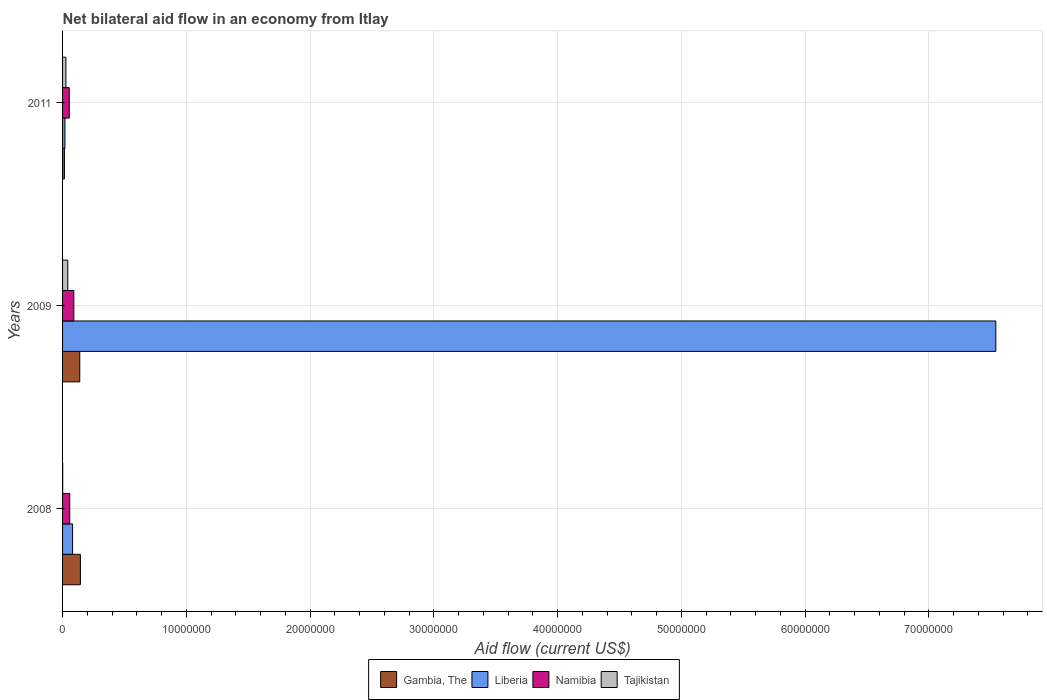How many different coloured bars are there?
Your answer should be compact. 4. How many groups of bars are there?
Offer a very short reply. 3. Are the number of bars per tick equal to the number of legend labels?
Offer a very short reply. Yes. Are the number of bars on each tick of the Y-axis equal?
Your response must be concise. Yes. How many bars are there on the 1st tick from the top?
Your answer should be compact. 4. How many bars are there on the 3rd tick from the bottom?
Make the answer very short. 4. In how many cases, is the number of bars for a given year not equal to the number of legend labels?
Offer a terse response. 0. What is the net bilateral aid flow in Liberia in 2008?
Provide a short and direct response. 8.10e+05. Across all years, what is the maximum net bilateral aid flow in Gambia, The?
Your answer should be compact. 1.44e+06. In which year was the net bilateral aid flow in Namibia minimum?
Keep it short and to the point. 2011. What is the difference between the net bilateral aid flow in Namibia in 2009 and that in 2011?
Provide a short and direct response. 3.70e+05. What is the difference between the net bilateral aid flow in Tajikistan in 2011 and the net bilateral aid flow in Liberia in 2008?
Offer a terse response. -5.40e+05. What is the average net bilateral aid flow in Liberia per year?
Your response must be concise. 2.55e+07. What is the ratio of the net bilateral aid flow in Namibia in 2008 to that in 2009?
Your answer should be very brief. 0.64. What is the difference between the highest and the second highest net bilateral aid flow in Liberia?
Provide a succinct answer. 7.46e+07. What is the difference between the highest and the lowest net bilateral aid flow in Tajikistan?
Offer a very short reply. 4.10e+05. What does the 1st bar from the top in 2009 represents?
Give a very brief answer. Tajikistan. What does the 1st bar from the bottom in 2011 represents?
Your answer should be very brief. Gambia, The. How many years are there in the graph?
Your answer should be very brief. 3. What is the difference between two consecutive major ticks on the X-axis?
Give a very brief answer. 1.00e+07. Does the graph contain any zero values?
Provide a succinct answer. No. Where does the legend appear in the graph?
Ensure brevity in your answer.  Bottom center. What is the title of the graph?
Offer a very short reply. Net bilateral aid flow in an economy from Itlay. What is the label or title of the X-axis?
Give a very brief answer. Aid flow (current US$). What is the label or title of the Y-axis?
Give a very brief answer. Years. What is the Aid flow (current US$) of Gambia, The in 2008?
Give a very brief answer. 1.44e+06. What is the Aid flow (current US$) in Liberia in 2008?
Your response must be concise. 8.10e+05. What is the Aid flow (current US$) in Namibia in 2008?
Your response must be concise. 5.80e+05. What is the Aid flow (current US$) in Tajikistan in 2008?
Your answer should be compact. 10000. What is the Aid flow (current US$) in Gambia, The in 2009?
Your answer should be very brief. 1.39e+06. What is the Aid flow (current US$) in Liberia in 2009?
Offer a very short reply. 7.54e+07. What is the Aid flow (current US$) in Namibia in 2009?
Offer a very short reply. 9.10e+05. What is the Aid flow (current US$) in Tajikistan in 2009?
Provide a succinct answer. 4.20e+05. What is the Aid flow (current US$) of Gambia, The in 2011?
Provide a succinct answer. 1.50e+05. What is the Aid flow (current US$) of Liberia in 2011?
Your answer should be compact. 1.90e+05. What is the Aid flow (current US$) of Namibia in 2011?
Provide a succinct answer. 5.40e+05. Across all years, what is the maximum Aid flow (current US$) in Gambia, The?
Your response must be concise. 1.44e+06. Across all years, what is the maximum Aid flow (current US$) of Liberia?
Offer a terse response. 7.54e+07. Across all years, what is the maximum Aid flow (current US$) in Namibia?
Give a very brief answer. 9.10e+05. Across all years, what is the maximum Aid flow (current US$) in Tajikistan?
Your answer should be very brief. 4.20e+05. Across all years, what is the minimum Aid flow (current US$) of Gambia, The?
Keep it short and to the point. 1.50e+05. Across all years, what is the minimum Aid flow (current US$) of Liberia?
Offer a very short reply. 1.90e+05. Across all years, what is the minimum Aid flow (current US$) in Namibia?
Your answer should be very brief. 5.40e+05. What is the total Aid flow (current US$) in Gambia, The in the graph?
Offer a terse response. 2.98e+06. What is the total Aid flow (current US$) of Liberia in the graph?
Give a very brief answer. 7.64e+07. What is the total Aid flow (current US$) of Namibia in the graph?
Offer a terse response. 2.03e+06. What is the total Aid flow (current US$) in Tajikistan in the graph?
Keep it short and to the point. 7.00e+05. What is the difference between the Aid flow (current US$) of Liberia in 2008 and that in 2009?
Make the answer very short. -7.46e+07. What is the difference between the Aid flow (current US$) of Namibia in 2008 and that in 2009?
Provide a succinct answer. -3.30e+05. What is the difference between the Aid flow (current US$) of Tajikistan in 2008 and that in 2009?
Make the answer very short. -4.10e+05. What is the difference between the Aid flow (current US$) of Gambia, The in 2008 and that in 2011?
Give a very brief answer. 1.29e+06. What is the difference between the Aid flow (current US$) of Liberia in 2008 and that in 2011?
Provide a short and direct response. 6.20e+05. What is the difference between the Aid flow (current US$) of Namibia in 2008 and that in 2011?
Provide a short and direct response. 4.00e+04. What is the difference between the Aid flow (current US$) in Gambia, The in 2009 and that in 2011?
Your response must be concise. 1.24e+06. What is the difference between the Aid flow (current US$) in Liberia in 2009 and that in 2011?
Offer a terse response. 7.52e+07. What is the difference between the Aid flow (current US$) in Namibia in 2009 and that in 2011?
Your answer should be compact. 3.70e+05. What is the difference between the Aid flow (current US$) in Tajikistan in 2009 and that in 2011?
Your answer should be compact. 1.50e+05. What is the difference between the Aid flow (current US$) of Gambia, The in 2008 and the Aid flow (current US$) of Liberia in 2009?
Your answer should be compact. -7.40e+07. What is the difference between the Aid flow (current US$) in Gambia, The in 2008 and the Aid flow (current US$) in Namibia in 2009?
Keep it short and to the point. 5.30e+05. What is the difference between the Aid flow (current US$) of Gambia, The in 2008 and the Aid flow (current US$) of Tajikistan in 2009?
Offer a terse response. 1.02e+06. What is the difference between the Aid flow (current US$) of Liberia in 2008 and the Aid flow (current US$) of Namibia in 2009?
Give a very brief answer. -1.00e+05. What is the difference between the Aid flow (current US$) of Gambia, The in 2008 and the Aid flow (current US$) of Liberia in 2011?
Offer a terse response. 1.25e+06. What is the difference between the Aid flow (current US$) in Gambia, The in 2008 and the Aid flow (current US$) in Tajikistan in 2011?
Provide a succinct answer. 1.17e+06. What is the difference between the Aid flow (current US$) of Liberia in 2008 and the Aid flow (current US$) of Tajikistan in 2011?
Make the answer very short. 5.40e+05. What is the difference between the Aid flow (current US$) in Gambia, The in 2009 and the Aid flow (current US$) in Liberia in 2011?
Your answer should be compact. 1.20e+06. What is the difference between the Aid flow (current US$) in Gambia, The in 2009 and the Aid flow (current US$) in Namibia in 2011?
Provide a succinct answer. 8.50e+05. What is the difference between the Aid flow (current US$) of Gambia, The in 2009 and the Aid flow (current US$) of Tajikistan in 2011?
Ensure brevity in your answer.  1.12e+06. What is the difference between the Aid flow (current US$) of Liberia in 2009 and the Aid flow (current US$) of Namibia in 2011?
Ensure brevity in your answer.  7.49e+07. What is the difference between the Aid flow (current US$) of Liberia in 2009 and the Aid flow (current US$) of Tajikistan in 2011?
Your response must be concise. 7.51e+07. What is the difference between the Aid flow (current US$) of Namibia in 2009 and the Aid flow (current US$) of Tajikistan in 2011?
Offer a terse response. 6.40e+05. What is the average Aid flow (current US$) in Gambia, The per year?
Your answer should be very brief. 9.93e+05. What is the average Aid flow (current US$) in Liberia per year?
Provide a succinct answer. 2.55e+07. What is the average Aid flow (current US$) of Namibia per year?
Provide a short and direct response. 6.77e+05. What is the average Aid flow (current US$) of Tajikistan per year?
Provide a succinct answer. 2.33e+05. In the year 2008, what is the difference between the Aid flow (current US$) in Gambia, The and Aid flow (current US$) in Liberia?
Provide a short and direct response. 6.30e+05. In the year 2008, what is the difference between the Aid flow (current US$) in Gambia, The and Aid flow (current US$) in Namibia?
Offer a very short reply. 8.60e+05. In the year 2008, what is the difference between the Aid flow (current US$) of Gambia, The and Aid flow (current US$) of Tajikistan?
Your answer should be very brief. 1.43e+06. In the year 2008, what is the difference between the Aid flow (current US$) of Namibia and Aid flow (current US$) of Tajikistan?
Ensure brevity in your answer.  5.70e+05. In the year 2009, what is the difference between the Aid flow (current US$) in Gambia, The and Aid flow (current US$) in Liberia?
Give a very brief answer. -7.40e+07. In the year 2009, what is the difference between the Aid flow (current US$) in Gambia, The and Aid flow (current US$) in Namibia?
Keep it short and to the point. 4.80e+05. In the year 2009, what is the difference between the Aid flow (current US$) of Gambia, The and Aid flow (current US$) of Tajikistan?
Ensure brevity in your answer.  9.70e+05. In the year 2009, what is the difference between the Aid flow (current US$) in Liberia and Aid flow (current US$) in Namibia?
Your response must be concise. 7.45e+07. In the year 2009, what is the difference between the Aid flow (current US$) of Liberia and Aid flow (current US$) of Tajikistan?
Offer a very short reply. 7.50e+07. In the year 2009, what is the difference between the Aid flow (current US$) in Namibia and Aid flow (current US$) in Tajikistan?
Provide a succinct answer. 4.90e+05. In the year 2011, what is the difference between the Aid flow (current US$) in Gambia, The and Aid flow (current US$) in Namibia?
Ensure brevity in your answer.  -3.90e+05. In the year 2011, what is the difference between the Aid flow (current US$) of Gambia, The and Aid flow (current US$) of Tajikistan?
Your answer should be compact. -1.20e+05. In the year 2011, what is the difference between the Aid flow (current US$) in Liberia and Aid flow (current US$) in Namibia?
Offer a terse response. -3.50e+05. In the year 2011, what is the difference between the Aid flow (current US$) of Liberia and Aid flow (current US$) of Tajikistan?
Give a very brief answer. -8.00e+04. In the year 2011, what is the difference between the Aid flow (current US$) of Namibia and Aid flow (current US$) of Tajikistan?
Ensure brevity in your answer.  2.70e+05. What is the ratio of the Aid flow (current US$) in Gambia, The in 2008 to that in 2009?
Ensure brevity in your answer.  1.04. What is the ratio of the Aid flow (current US$) of Liberia in 2008 to that in 2009?
Provide a short and direct response. 0.01. What is the ratio of the Aid flow (current US$) in Namibia in 2008 to that in 2009?
Your answer should be compact. 0.64. What is the ratio of the Aid flow (current US$) in Tajikistan in 2008 to that in 2009?
Your answer should be very brief. 0.02. What is the ratio of the Aid flow (current US$) in Gambia, The in 2008 to that in 2011?
Make the answer very short. 9.6. What is the ratio of the Aid flow (current US$) of Liberia in 2008 to that in 2011?
Your response must be concise. 4.26. What is the ratio of the Aid flow (current US$) of Namibia in 2008 to that in 2011?
Provide a succinct answer. 1.07. What is the ratio of the Aid flow (current US$) of Tajikistan in 2008 to that in 2011?
Your answer should be very brief. 0.04. What is the ratio of the Aid flow (current US$) in Gambia, The in 2009 to that in 2011?
Keep it short and to the point. 9.27. What is the ratio of the Aid flow (current US$) in Liberia in 2009 to that in 2011?
Make the answer very short. 396.89. What is the ratio of the Aid flow (current US$) in Namibia in 2009 to that in 2011?
Keep it short and to the point. 1.69. What is the ratio of the Aid flow (current US$) of Tajikistan in 2009 to that in 2011?
Make the answer very short. 1.56. What is the difference between the highest and the second highest Aid flow (current US$) of Gambia, The?
Give a very brief answer. 5.00e+04. What is the difference between the highest and the second highest Aid flow (current US$) of Liberia?
Provide a short and direct response. 7.46e+07. What is the difference between the highest and the lowest Aid flow (current US$) in Gambia, The?
Your answer should be very brief. 1.29e+06. What is the difference between the highest and the lowest Aid flow (current US$) in Liberia?
Provide a succinct answer. 7.52e+07. What is the difference between the highest and the lowest Aid flow (current US$) in Namibia?
Provide a succinct answer. 3.70e+05. What is the difference between the highest and the lowest Aid flow (current US$) of Tajikistan?
Your response must be concise. 4.10e+05. 